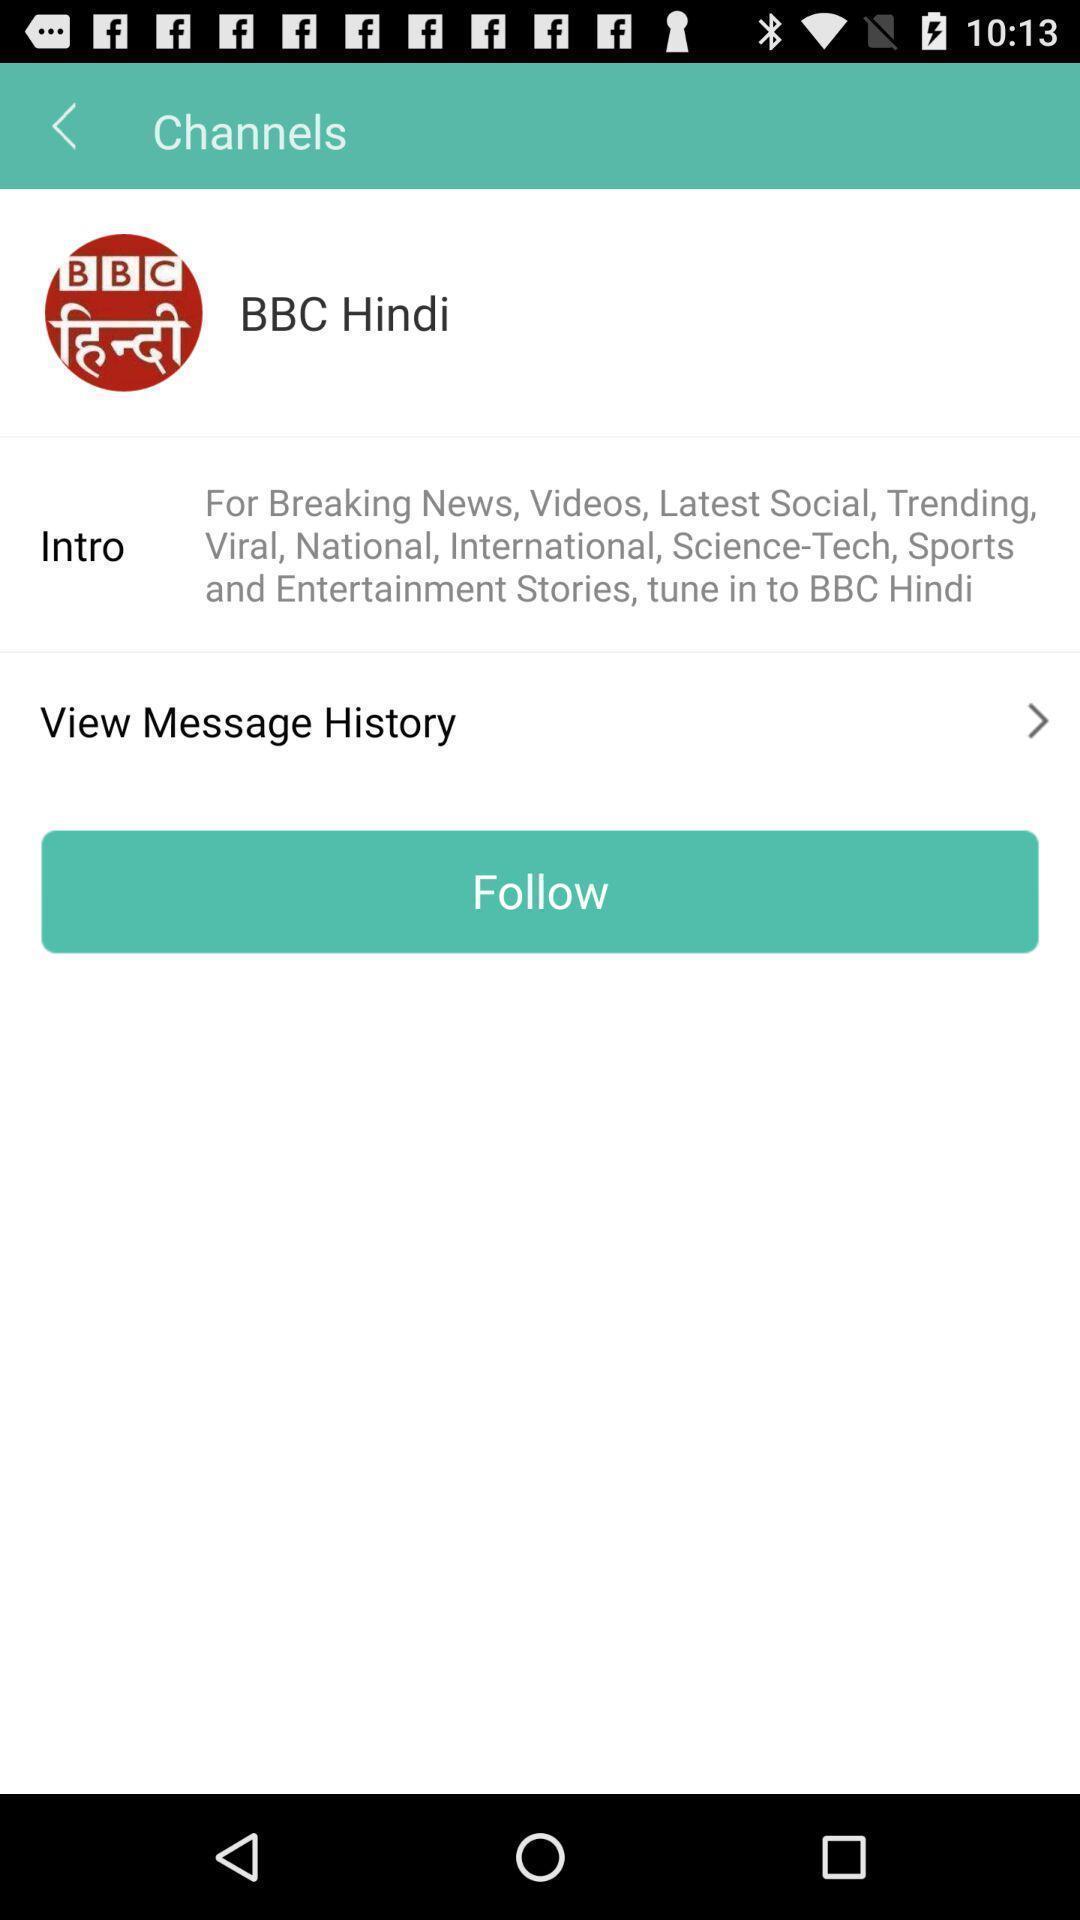Describe this image in words. Page showing option for message history. 